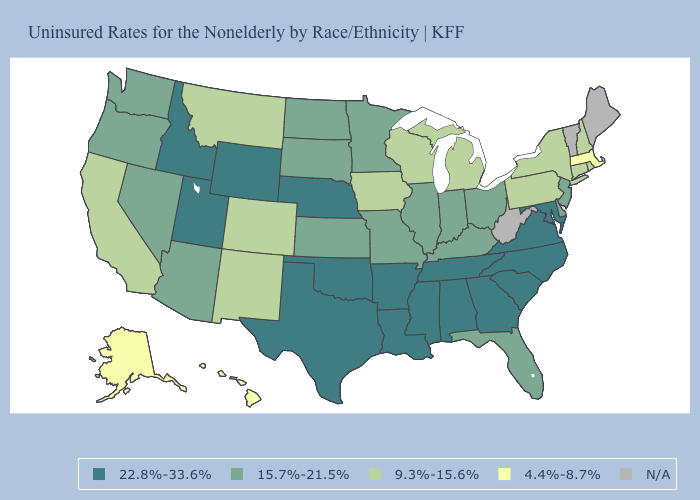What is the lowest value in the USA?
Keep it brief. 4.4%-8.7%. Does the first symbol in the legend represent the smallest category?
Short answer required. No. Does Utah have the highest value in the West?
Write a very short answer. Yes. Name the states that have a value in the range 4.4%-8.7%?
Short answer required. Alaska, Hawaii, Massachusetts. Does Utah have the highest value in the USA?
Keep it brief. Yes. Name the states that have a value in the range 9.3%-15.6%?
Be succinct. California, Colorado, Connecticut, Iowa, Michigan, Montana, New Hampshire, New Mexico, New York, Pennsylvania, Rhode Island, Wisconsin. Name the states that have a value in the range 9.3%-15.6%?
Answer briefly. California, Colorado, Connecticut, Iowa, Michigan, Montana, New Hampshire, New Mexico, New York, Pennsylvania, Rhode Island, Wisconsin. Name the states that have a value in the range 15.7%-21.5%?
Write a very short answer. Arizona, Delaware, Florida, Illinois, Indiana, Kansas, Kentucky, Minnesota, Missouri, Nevada, New Jersey, North Dakota, Ohio, Oregon, South Dakota, Washington. How many symbols are there in the legend?
Give a very brief answer. 5. Does Wyoming have the highest value in the West?
Give a very brief answer. Yes. What is the lowest value in states that border Utah?
Give a very brief answer. 9.3%-15.6%. What is the value of New Jersey?
Short answer required. 15.7%-21.5%. Name the states that have a value in the range 9.3%-15.6%?
Answer briefly. California, Colorado, Connecticut, Iowa, Michigan, Montana, New Hampshire, New Mexico, New York, Pennsylvania, Rhode Island, Wisconsin. Which states hav the highest value in the South?
Short answer required. Alabama, Arkansas, Georgia, Louisiana, Maryland, Mississippi, North Carolina, Oklahoma, South Carolina, Tennessee, Texas, Virginia. 